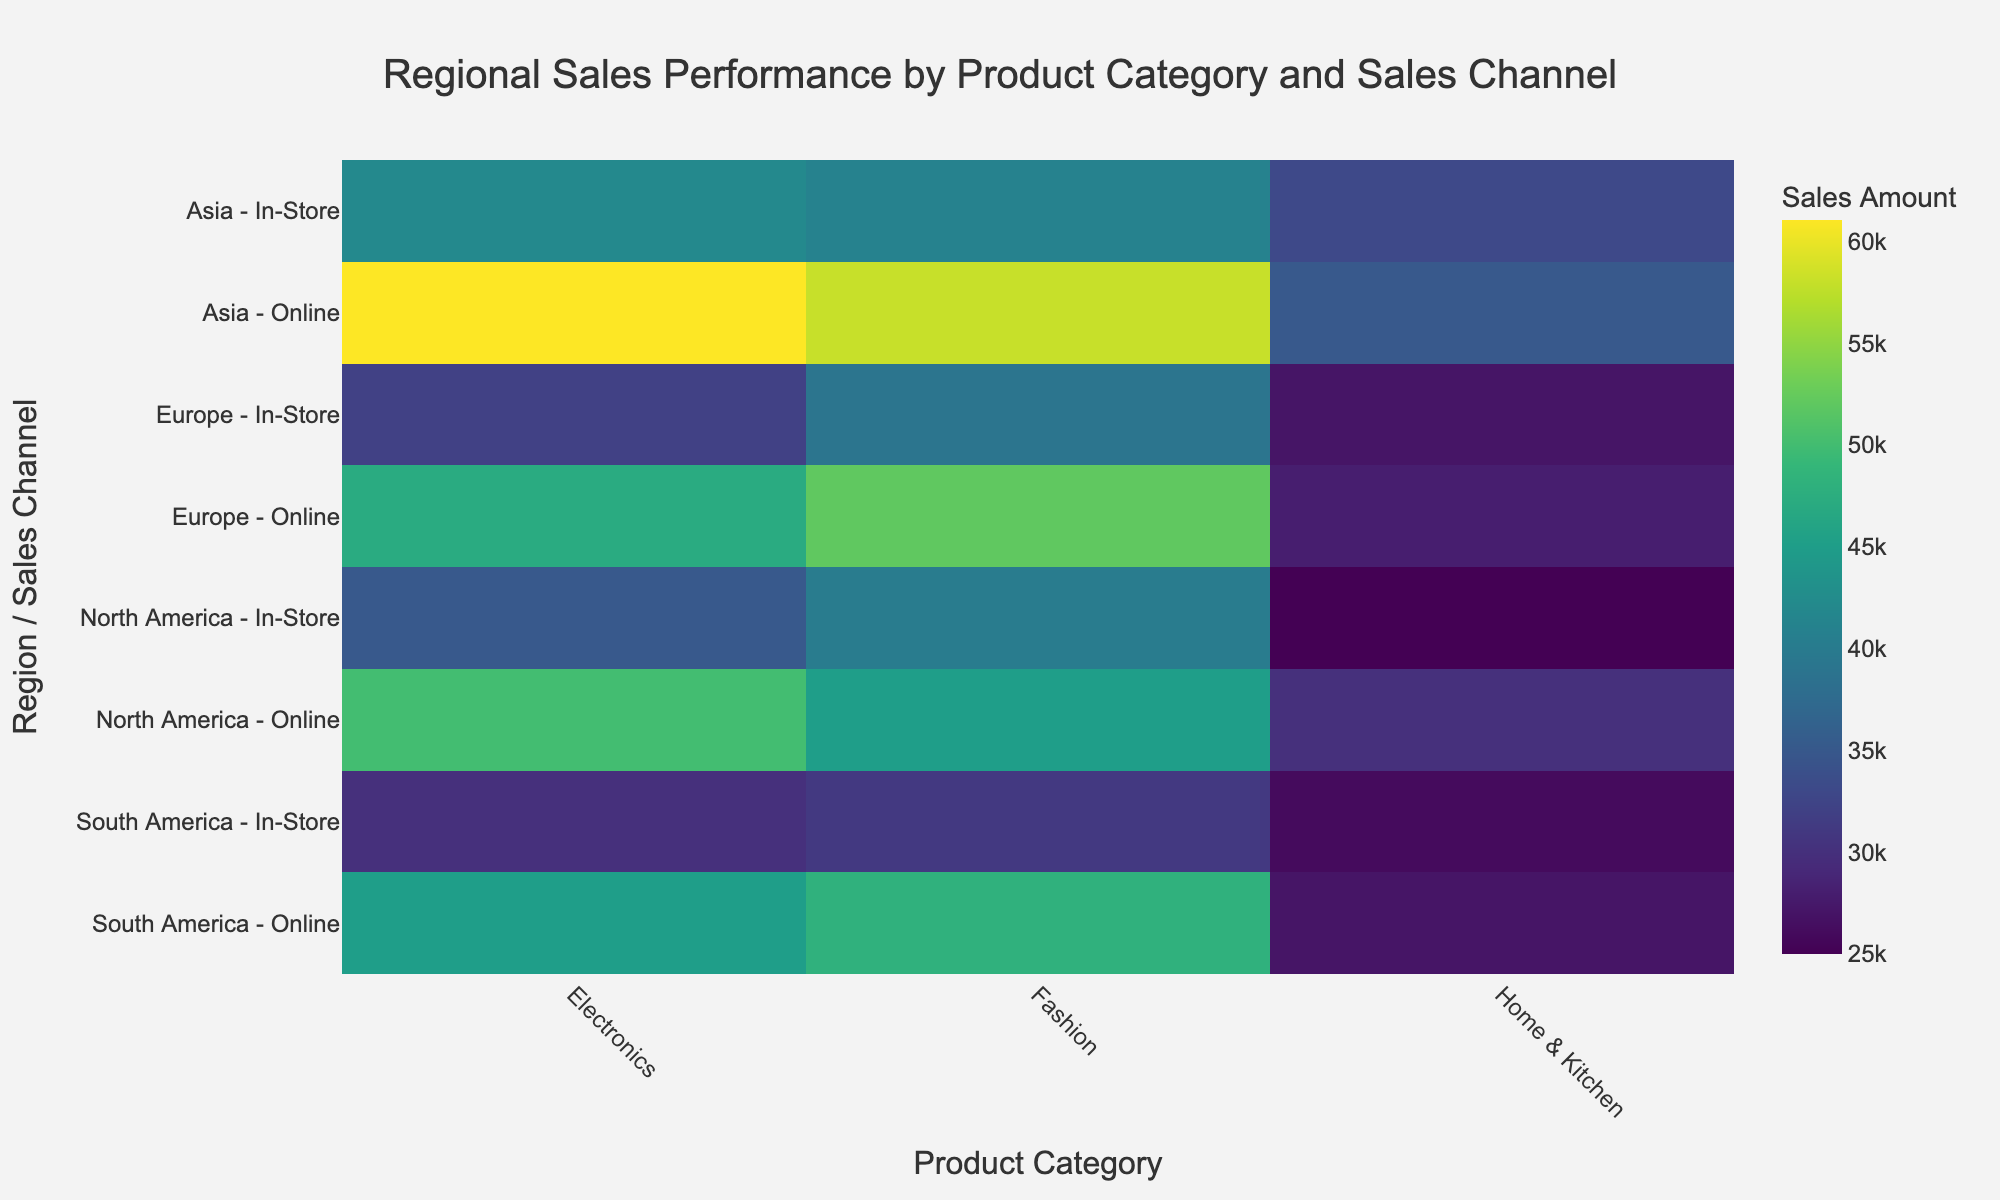what is the highest sales amount and for which combination does it occur? The heatmap shows the sales amount for different regions, product categories, and sales channels. We need to find the highest value. The value of $61,000 is the highest and it occurs for the combination of Asia, Electronics, and Online.
Answer: $61,000 for Asia, Electronics, Online What's the color range used in the figure, and what does it signify? The heatmap uses a color scale to represent sales amounts. The 'Viridis' color scale is used, which ranges from dark purple (low sales) to yellow (high sales). The color intensity indicates the amount of sales, with deeper colors corresponding to higher values.
Answer: Dark purple to yellow, representing low to high sales How do the sales amounts for Electronics in Asia compare across Online and In-Store channels? We need to check the sales amounts for Electronics in Asia across both channels. The heatmap shows $61,000 for Online and $42,000 for In-Store. Comparing these, Online sales are higher than In-Store sales by $61,000 - $42,000 = $19,000.
Answer: Online is higher by $19,000 Which region has the lowest sales in the Home & Kitchen category, and through which channel? By scanning the Home & Kitchen category for all regions, we can identify the lowest sales amount. The value of $25,000 is found to be the lowest, and it occurs in North America through the In-Store channel.
Answer: North America, In-Store, for $25,000 What is the overall sales performance in Europe for Fashion across both sales channels? We need to sum the sales amounts for Fashion in Europe across both Online and In-Store channels. The heatmap shows $52,000 for Online and $39,000 for In-Store, so the total is $52,000 + $39,000 = $91,000.
Answer: $91,000 What's the difference in sales amounts between Electronics and Home & Kitchen in South America for Online channels? Checking South America's Online channel, the sales amount for Electronics is $45,000 and for Home & Kitchen is $27,000. The difference is $45,000 - $27,000 = $18,000.
Answer: $18,000 Explain the sales performance for North America in the Fashion category, in comparison to Electronics. For North America, we compare Fashion and Electronics. Fashion has $45,000 Online and $40,000 In-Store, summing to $85,000. Electronics has $50,000 Online and $35,000 In-Store, summing to $85,000. Both categories have equal total sales amounts.
Answer: They are equal at $85,000 Which region showed the highest total sales in all categories combined? Sum the sales for all categories and channels in each region:
- North America: (50000+35000+45000+40000+30000+25000) = $225,000
- Europe: (47000+32000+52000+39000+28000+27000) = $225,000
- Asia: (61000+42000+58000+41000+35000+33000) = $270,000
- South America: (45000+30000+48000+31000+27000+26000) = $207,000
Asia shows the highest total sales.
Answer: Asia with $270,000 